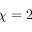Convert formula to latex. <formula><loc_0><loc_0><loc_500><loc_500>\chi = 2</formula> 